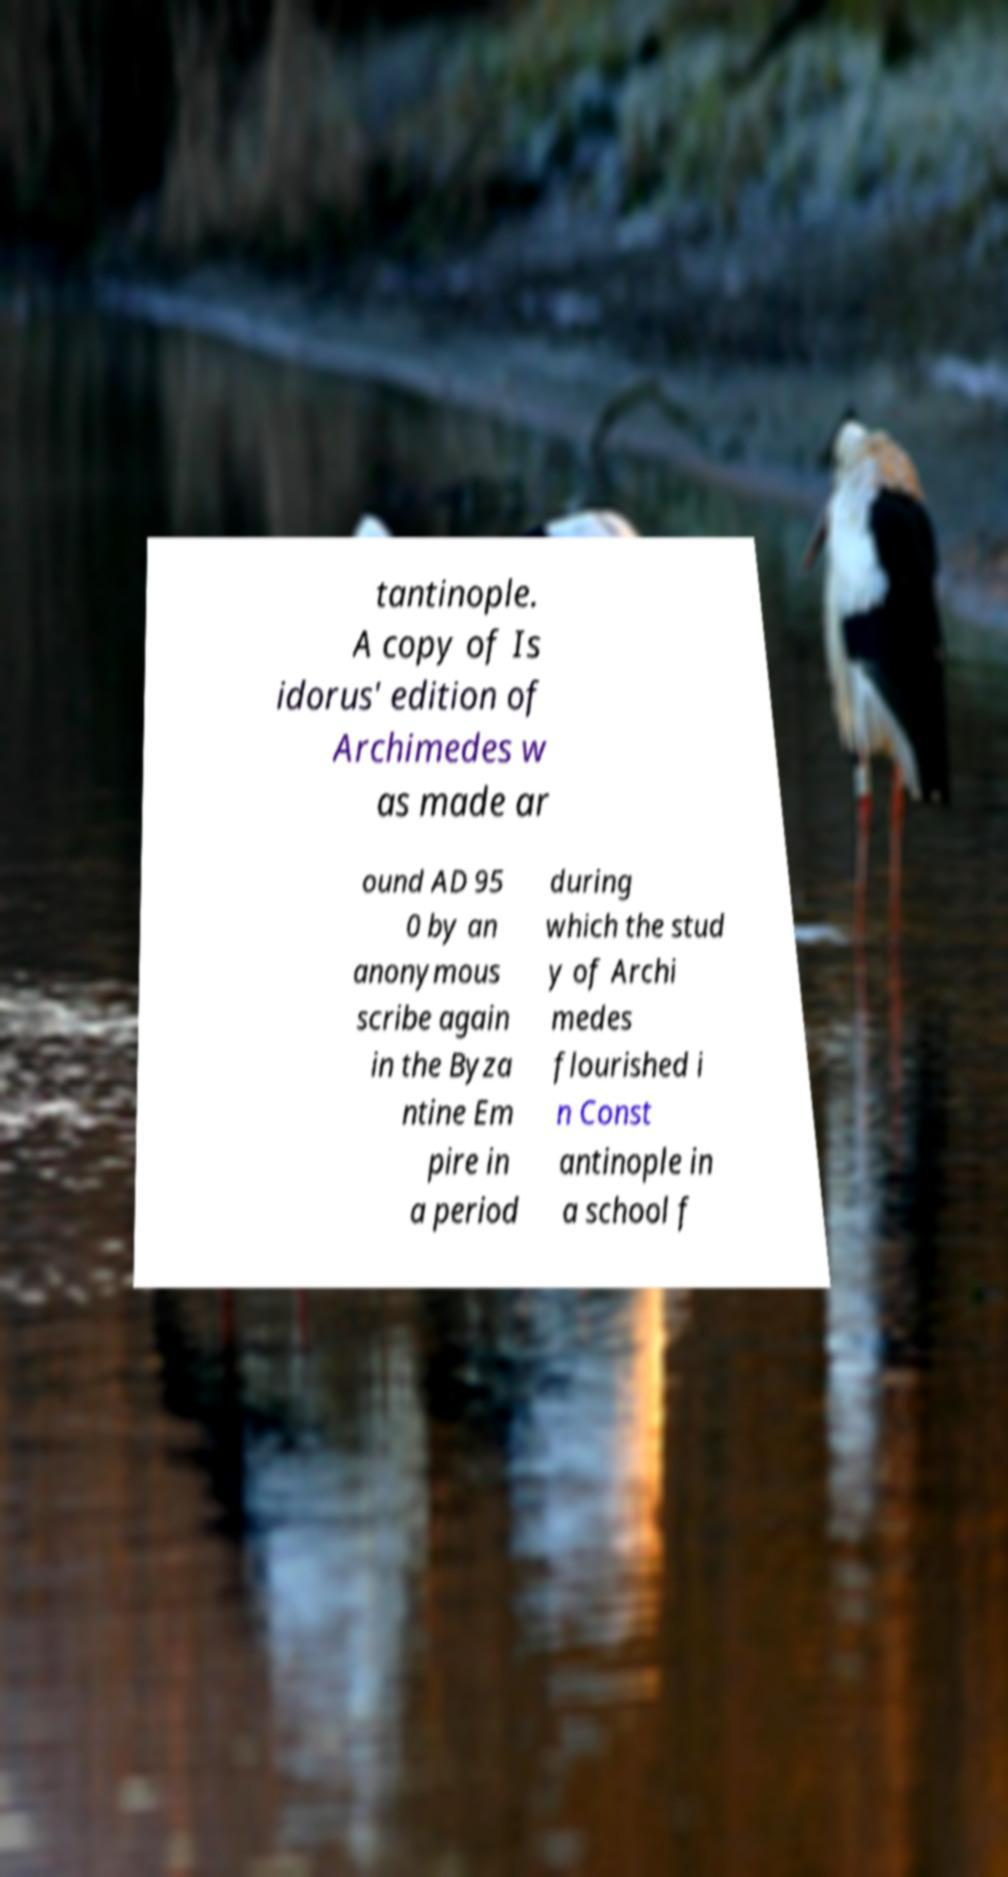Please identify and transcribe the text found in this image. tantinople. A copy of Is idorus' edition of Archimedes w as made ar ound AD 95 0 by an anonymous scribe again in the Byza ntine Em pire in a period during which the stud y of Archi medes flourished i n Const antinople in a school f 